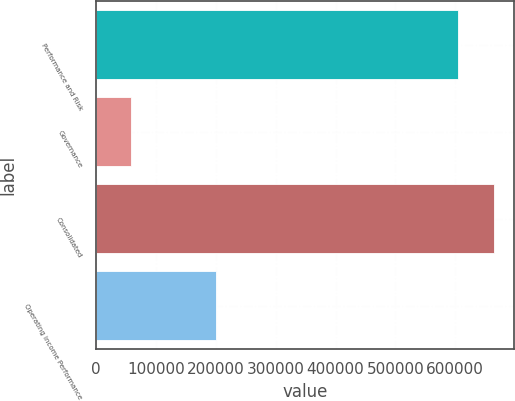Convert chart. <chart><loc_0><loc_0><loc_500><loc_500><bar_chart><fcel>Performance and Risk<fcel>Governance<fcel>Consolidated<fcel>Operating income Performance<nl><fcel>604307<fcel>58594<fcel>664738<fcel>200369<nl></chart> 